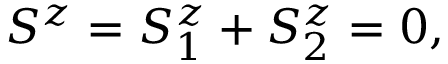<formula> <loc_0><loc_0><loc_500><loc_500>S ^ { z } = S _ { 1 } ^ { z } + S _ { 2 } ^ { z } = 0 ,</formula> 